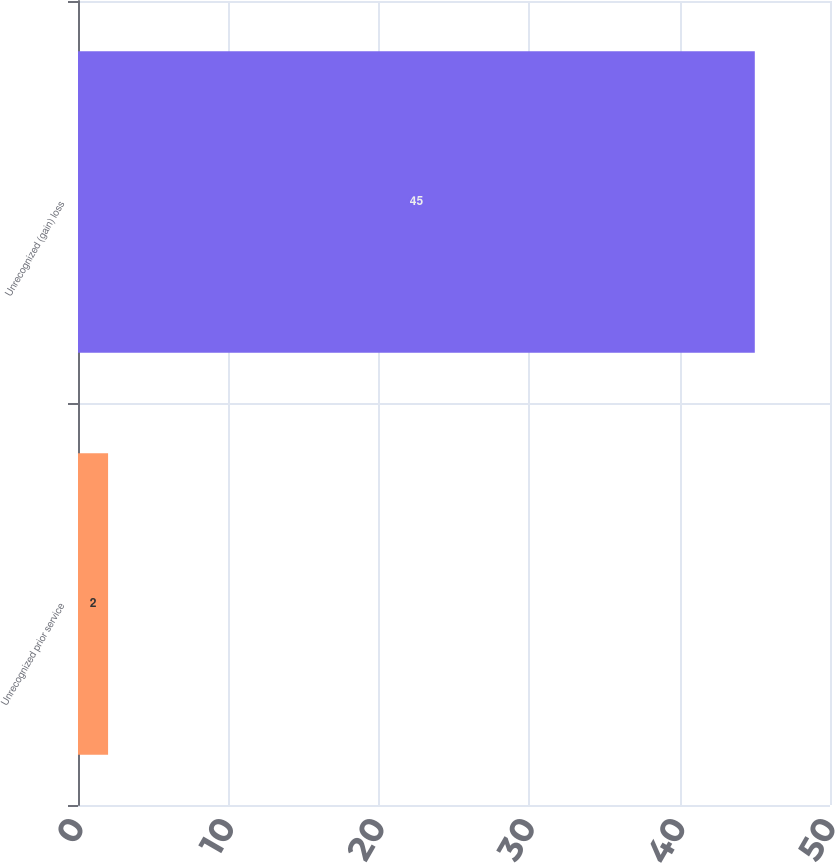<chart> <loc_0><loc_0><loc_500><loc_500><bar_chart><fcel>Unrecognized prior service<fcel>Unrecognized (gain) loss<nl><fcel>2<fcel>45<nl></chart> 